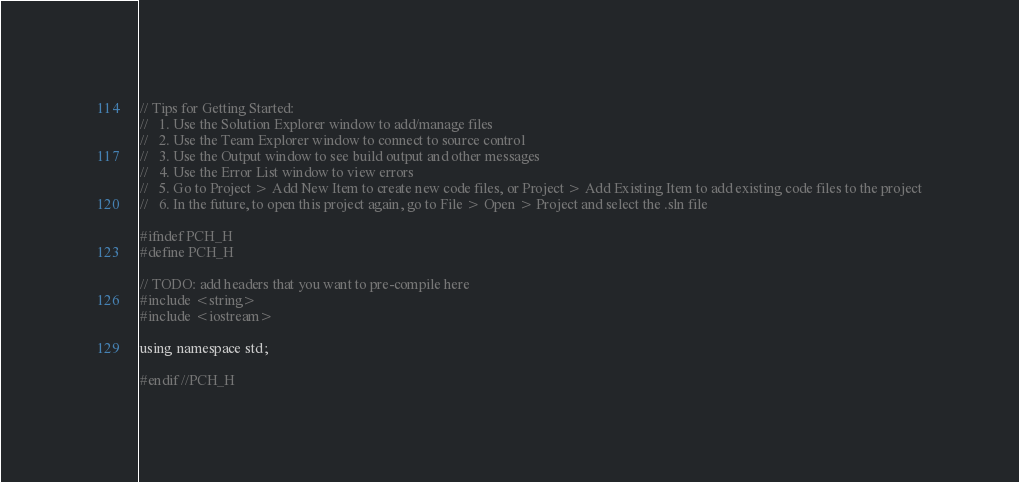<code> <loc_0><loc_0><loc_500><loc_500><_C_>// Tips for Getting Started: 
//   1. Use the Solution Explorer window to add/manage files
//   2. Use the Team Explorer window to connect to source control
//   3. Use the Output window to see build output and other messages
//   4. Use the Error List window to view errors
//   5. Go to Project > Add New Item to create new code files, or Project > Add Existing Item to add existing code files to the project
//   6. In the future, to open this project again, go to File > Open > Project and select the .sln file

#ifndef PCH_H
#define PCH_H

// TODO: add headers that you want to pre-compile here
#include <string> 
#include <iostream>

using namespace std;

#endif //PCH_H
</code> 